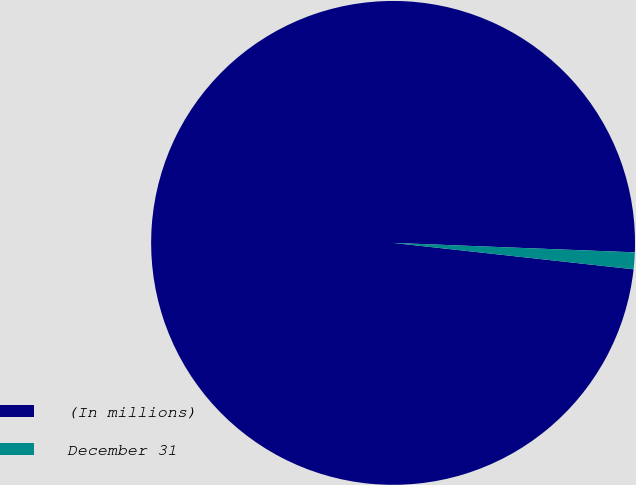<chart> <loc_0><loc_0><loc_500><loc_500><pie_chart><fcel>(In millions)<fcel>December 31<nl><fcel>98.88%<fcel>1.12%<nl></chart> 